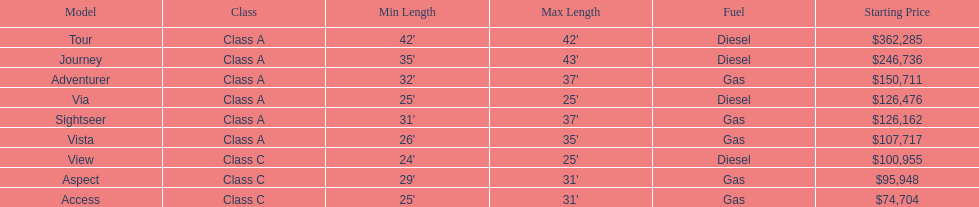What is the price of bot the via and tour models combined? $488,761. 